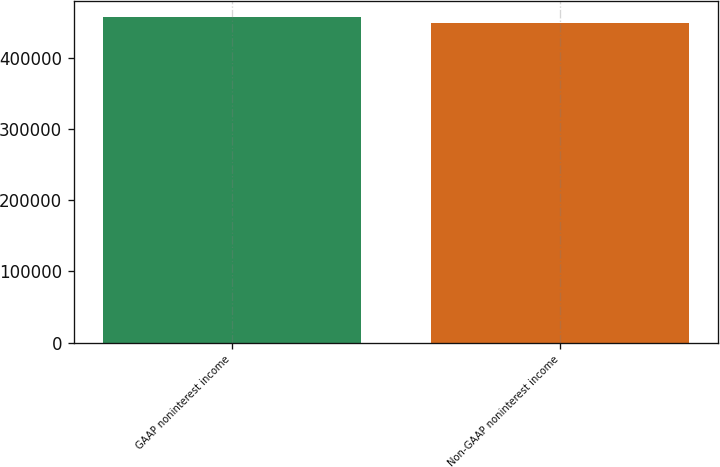Convert chart to OTSL. <chart><loc_0><loc_0><loc_500><loc_500><bar_chart><fcel>GAAP noninterest income<fcel>Non-GAAP noninterest income<nl><fcel>456552<fcel>448513<nl></chart> 